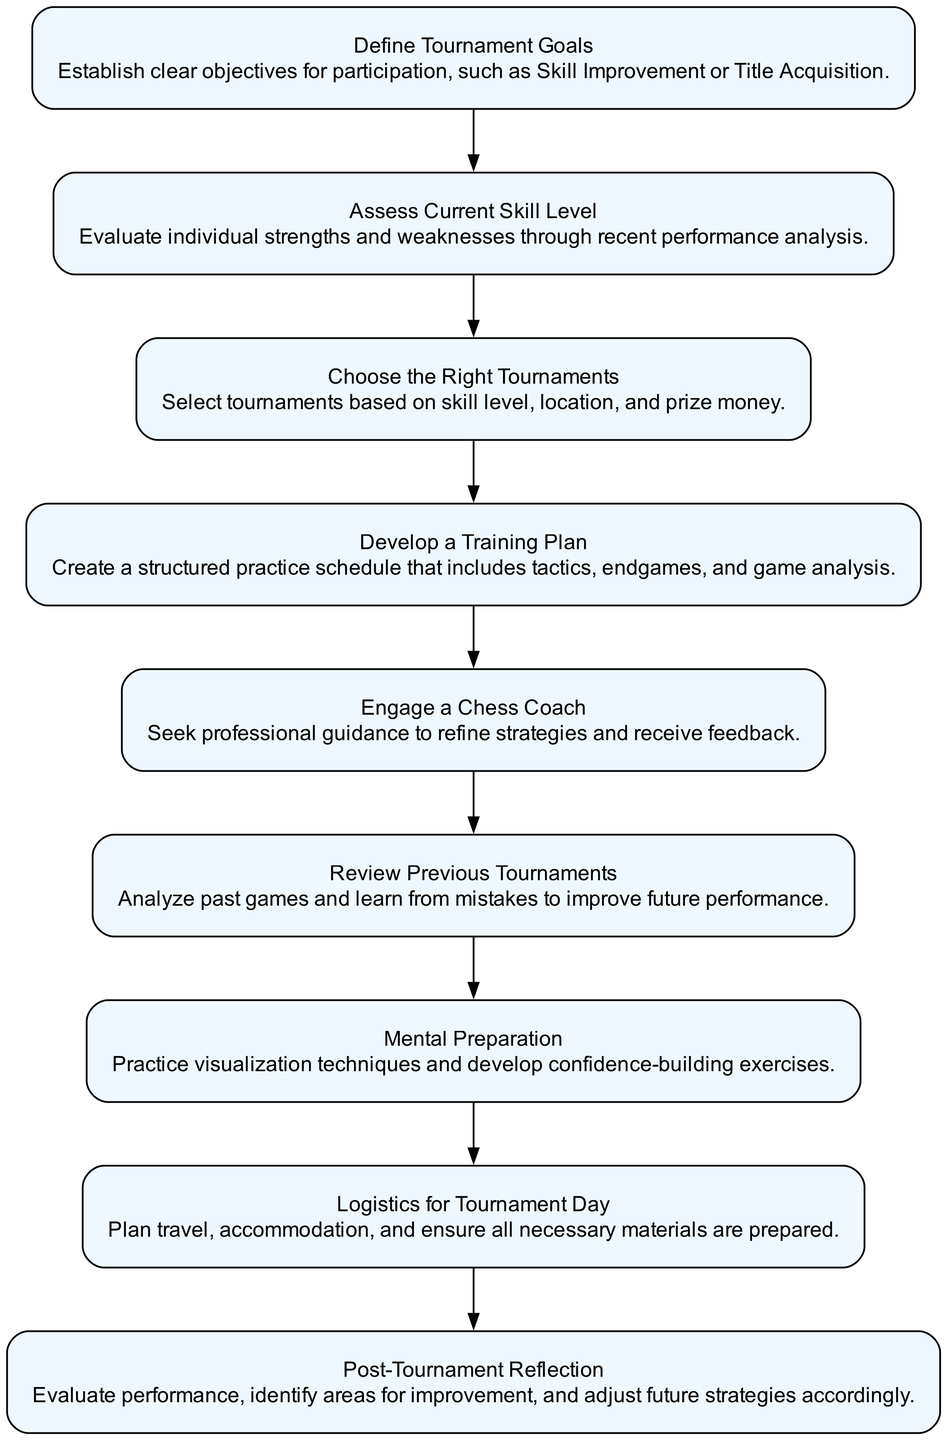What is the first step in the tournament preparation flow? The first step is to define tournament goals as indicated by the first node in the flow chart.
Answer: Define Tournament Goals How many total steps are there in the preparation flow? Counting all the nodes in the flow chart, there are nine steps listed sequentially from start to finish.
Answer: Nine What is the last step in the chess tournament preparation? The last step in the flow is to reflect on performance after the tournament as shown in the final node of the diagram.
Answer: Post-Tournament Reflection Which step comes immediately after "Choose the Right Tournaments"? The diagram indicates that the next step following "Choose the Right Tournaments" is "Develop a Training Plan".
Answer: Develop a Training Plan What is the significance of the "Engage a Chess Coach" node? This step emphasizes the importance of receiving professional guidance to improve strategies, as noted in its description in the flow.
Answer: Professional guidance What two types of preparation are involved in the mental preparation step? The mental preparation step focuses on visualization techniques and confidence-building exercises, as seen in its description.
Answer: Visualization techniques and confidence-building exercises How does the "Review Previous Tournaments" step relate to "Post-Tournament Reflection"? "Review Previous Tournaments" provides insights that help in the reflection of performance after the current tournament, creating a feedback loop for continuous improvement.
Answer: Continuous improvement In what order do "Develop a Training Plan" and "Engage a Chess Coach" occur? The diagram shows that "Develop a Training Plan" is to be completed before "Engage a Chess Coach", establishing a structured framework first.
Answer: Develop a Training Plan then Engage a Chess Coach What does the "Logistics for Tournament Day" step encompass? This step covers essential preparations such as planning travel, accommodation, and ensuring all materials are ready for the tournament day.
Answer: Plan travel, accommodation, and ensure materials are ready 